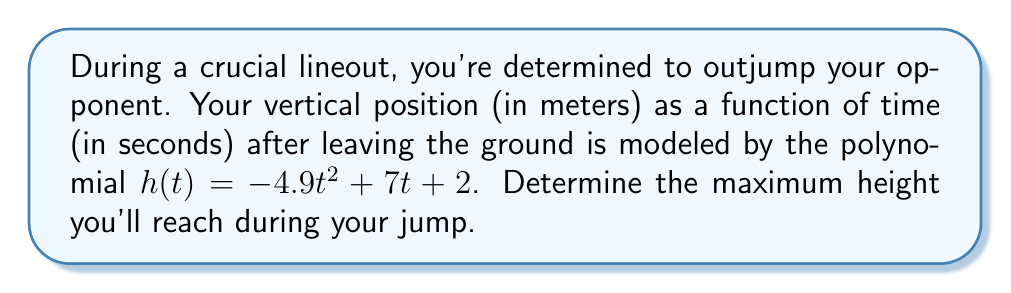Teach me how to tackle this problem. To find the maximum height of the jump, we need to find the vertex of the parabola described by the given quadratic function. The steps are as follows:

1) The quadratic function is in the form $h(t) = at^2 + bt + c$, where:
   $a = -4.9$
   $b = 7$
   $c = 2$

2) For a quadratic function, the t-coordinate of the vertex is given by $t = -\frac{b}{2a}$:

   $t = -\frac{7}{2(-4.9)} = \frac{7}{9.8} \approx 0.714$ seconds

3) To find the maximum height, we substitute this t-value back into the original function:

   $h(0.714) = -4.9(0.714)^2 + 7(0.714) + 2$

4) Calculating this:
   $h(0.714) = -4.9(0.510) + 5 + 2$
   $h(0.714) = -2.499 + 7$
   $h(0.714) = 4.501$ meters

Therefore, the maximum height reached is approximately 4.501 meters.
Answer: The maximum height reached during the jump is approximately 4.501 meters. 